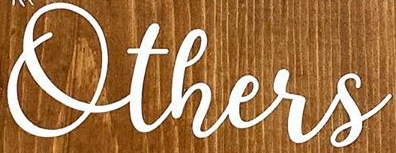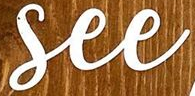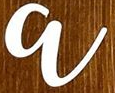What words can you see in these images in sequence, separated by a semicolon? Others; See; a 